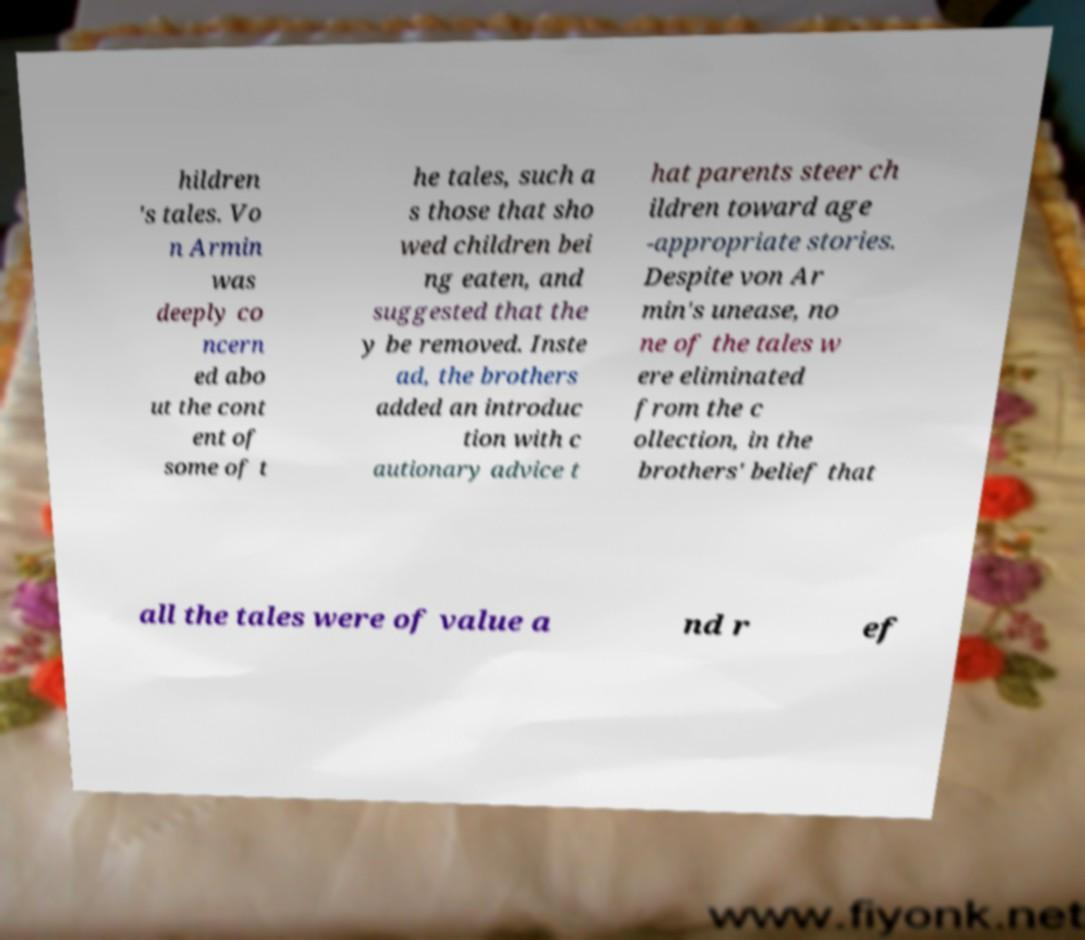What messages or text are displayed in this image? I need them in a readable, typed format. hildren 's tales. Vo n Armin was deeply co ncern ed abo ut the cont ent of some of t he tales, such a s those that sho wed children bei ng eaten, and suggested that the y be removed. Inste ad, the brothers added an introduc tion with c autionary advice t hat parents steer ch ildren toward age -appropriate stories. Despite von Ar min's unease, no ne of the tales w ere eliminated from the c ollection, in the brothers' belief that all the tales were of value a nd r ef 